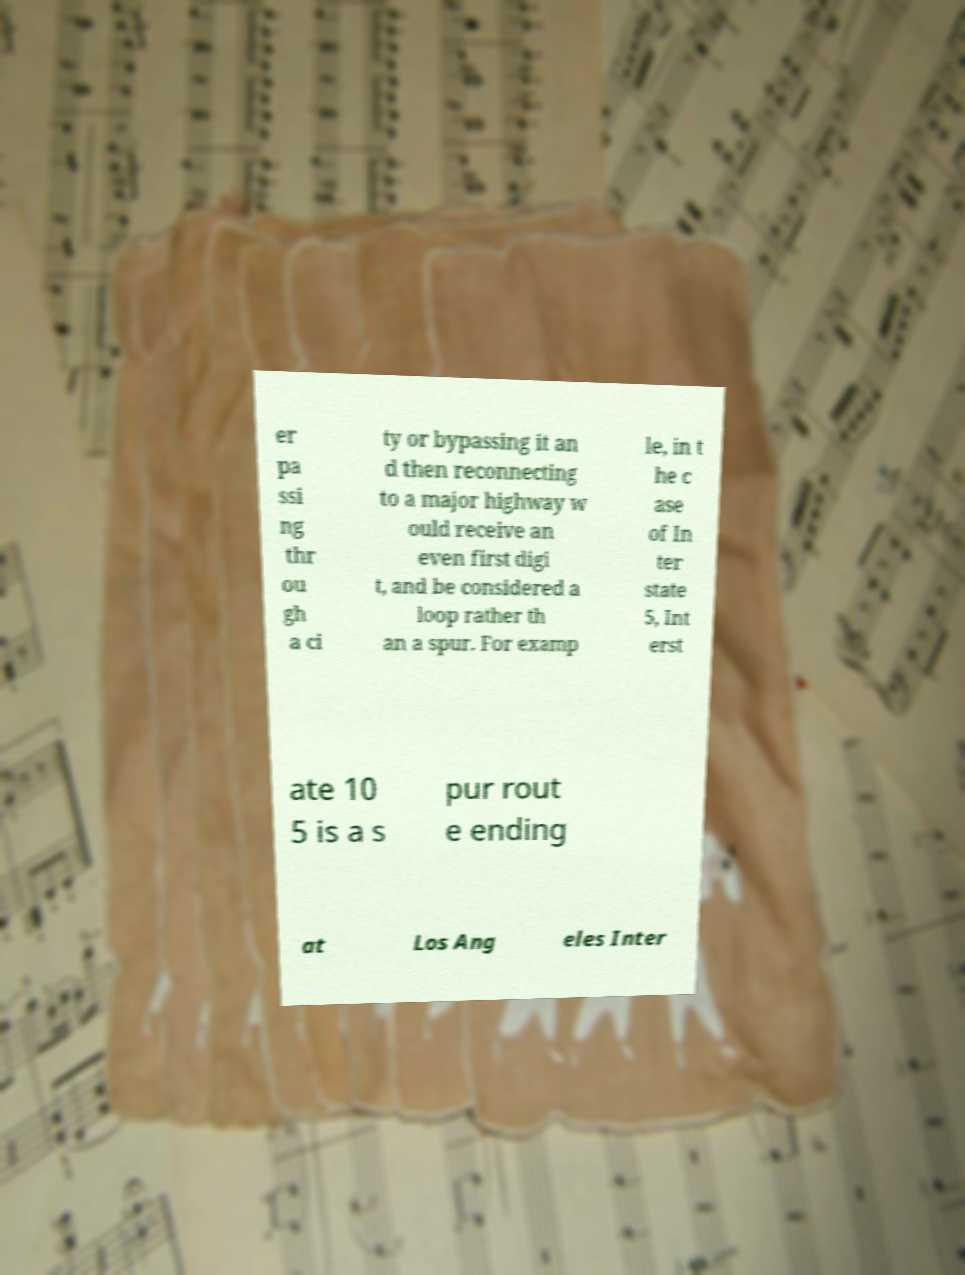Please read and relay the text visible in this image. What does it say? er pa ssi ng thr ou gh a ci ty or bypassing it an d then reconnecting to a major highway w ould receive an even first digi t, and be considered a loop rather th an a spur. For examp le, in t he c ase of In ter state 5, Int erst ate 10 5 is a s pur rout e ending at Los Ang eles Inter 